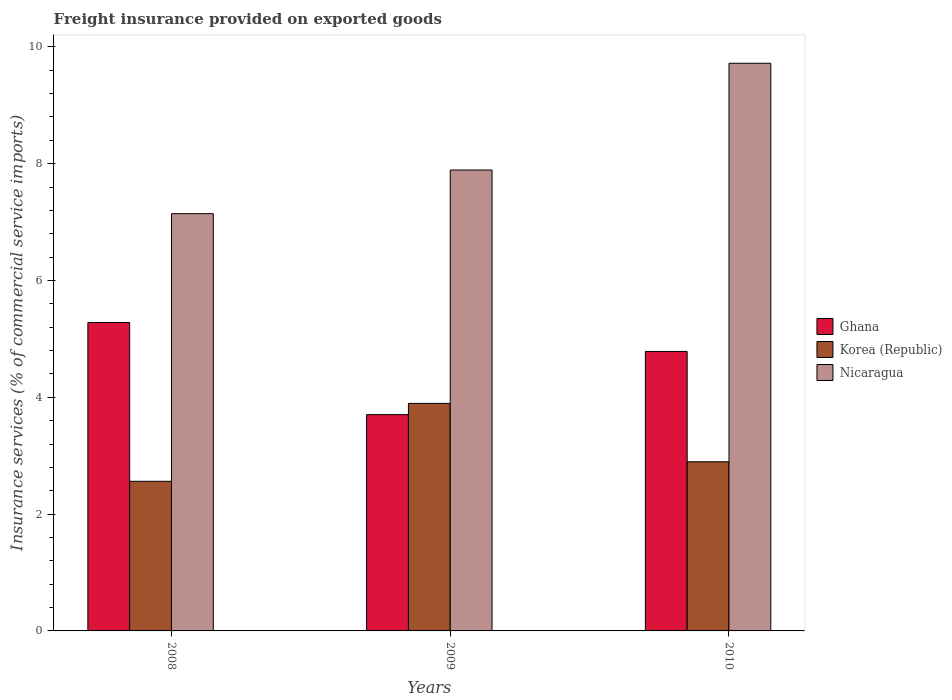Are the number of bars per tick equal to the number of legend labels?
Offer a terse response. Yes. How many bars are there on the 1st tick from the left?
Make the answer very short. 3. How many bars are there on the 1st tick from the right?
Your answer should be compact. 3. What is the label of the 2nd group of bars from the left?
Offer a very short reply. 2009. In how many cases, is the number of bars for a given year not equal to the number of legend labels?
Offer a terse response. 0. What is the freight insurance provided on exported goods in Nicaragua in 2008?
Provide a short and direct response. 7.14. Across all years, what is the maximum freight insurance provided on exported goods in Nicaragua?
Offer a very short reply. 9.72. Across all years, what is the minimum freight insurance provided on exported goods in Ghana?
Ensure brevity in your answer.  3.7. What is the total freight insurance provided on exported goods in Korea (Republic) in the graph?
Provide a short and direct response. 9.35. What is the difference between the freight insurance provided on exported goods in Nicaragua in 2008 and that in 2010?
Your answer should be compact. -2.58. What is the difference between the freight insurance provided on exported goods in Ghana in 2010 and the freight insurance provided on exported goods in Nicaragua in 2009?
Provide a short and direct response. -3.11. What is the average freight insurance provided on exported goods in Korea (Republic) per year?
Ensure brevity in your answer.  3.12. In the year 2010, what is the difference between the freight insurance provided on exported goods in Nicaragua and freight insurance provided on exported goods in Ghana?
Your response must be concise. 4.93. In how many years, is the freight insurance provided on exported goods in Korea (Republic) greater than 0.4 %?
Your response must be concise. 3. What is the ratio of the freight insurance provided on exported goods in Ghana in 2009 to that in 2010?
Ensure brevity in your answer.  0.77. Is the freight insurance provided on exported goods in Ghana in 2009 less than that in 2010?
Your answer should be very brief. Yes. Is the difference between the freight insurance provided on exported goods in Nicaragua in 2008 and 2010 greater than the difference between the freight insurance provided on exported goods in Ghana in 2008 and 2010?
Provide a short and direct response. No. What is the difference between the highest and the second highest freight insurance provided on exported goods in Ghana?
Give a very brief answer. 0.5. What is the difference between the highest and the lowest freight insurance provided on exported goods in Ghana?
Provide a succinct answer. 1.58. In how many years, is the freight insurance provided on exported goods in Korea (Republic) greater than the average freight insurance provided on exported goods in Korea (Republic) taken over all years?
Give a very brief answer. 1. Is the sum of the freight insurance provided on exported goods in Nicaragua in 2008 and 2009 greater than the maximum freight insurance provided on exported goods in Ghana across all years?
Your answer should be very brief. Yes. What does the 3rd bar from the left in 2008 represents?
Give a very brief answer. Nicaragua. How many years are there in the graph?
Your answer should be very brief. 3. Are the values on the major ticks of Y-axis written in scientific E-notation?
Offer a very short reply. No. Does the graph contain any zero values?
Your response must be concise. No. Where does the legend appear in the graph?
Ensure brevity in your answer.  Center right. How are the legend labels stacked?
Provide a succinct answer. Vertical. What is the title of the graph?
Your answer should be compact. Freight insurance provided on exported goods. What is the label or title of the X-axis?
Your answer should be compact. Years. What is the label or title of the Y-axis?
Provide a succinct answer. Insurance services (% of commercial service imports). What is the Insurance services (% of commercial service imports) in Ghana in 2008?
Give a very brief answer. 5.28. What is the Insurance services (% of commercial service imports) of Korea (Republic) in 2008?
Make the answer very short. 2.56. What is the Insurance services (% of commercial service imports) in Nicaragua in 2008?
Provide a succinct answer. 7.14. What is the Insurance services (% of commercial service imports) in Ghana in 2009?
Keep it short and to the point. 3.7. What is the Insurance services (% of commercial service imports) of Korea (Republic) in 2009?
Your answer should be compact. 3.9. What is the Insurance services (% of commercial service imports) of Nicaragua in 2009?
Offer a terse response. 7.89. What is the Insurance services (% of commercial service imports) in Ghana in 2010?
Provide a succinct answer. 4.79. What is the Insurance services (% of commercial service imports) in Korea (Republic) in 2010?
Offer a very short reply. 2.9. What is the Insurance services (% of commercial service imports) of Nicaragua in 2010?
Keep it short and to the point. 9.72. Across all years, what is the maximum Insurance services (% of commercial service imports) of Ghana?
Make the answer very short. 5.28. Across all years, what is the maximum Insurance services (% of commercial service imports) in Korea (Republic)?
Provide a short and direct response. 3.9. Across all years, what is the maximum Insurance services (% of commercial service imports) in Nicaragua?
Keep it short and to the point. 9.72. Across all years, what is the minimum Insurance services (% of commercial service imports) in Ghana?
Offer a very short reply. 3.7. Across all years, what is the minimum Insurance services (% of commercial service imports) of Korea (Republic)?
Provide a short and direct response. 2.56. Across all years, what is the minimum Insurance services (% of commercial service imports) in Nicaragua?
Offer a terse response. 7.14. What is the total Insurance services (% of commercial service imports) of Ghana in the graph?
Your response must be concise. 13.77. What is the total Insurance services (% of commercial service imports) in Korea (Republic) in the graph?
Ensure brevity in your answer.  9.35. What is the total Insurance services (% of commercial service imports) in Nicaragua in the graph?
Offer a terse response. 24.75. What is the difference between the Insurance services (% of commercial service imports) of Ghana in 2008 and that in 2009?
Provide a succinct answer. 1.58. What is the difference between the Insurance services (% of commercial service imports) in Korea (Republic) in 2008 and that in 2009?
Ensure brevity in your answer.  -1.33. What is the difference between the Insurance services (% of commercial service imports) in Nicaragua in 2008 and that in 2009?
Ensure brevity in your answer.  -0.75. What is the difference between the Insurance services (% of commercial service imports) of Ghana in 2008 and that in 2010?
Your response must be concise. 0.5. What is the difference between the Insurance services (% of commercial service imports) in Korea (Republic) in 2008 and that in 2010?
Offer a very short reply. -0.33. What is the difference between the Insurance services (% of commercial service imports) of Nicaragua in 2008 and that in 2010?
Provide a short and direct response. -2.58. What is the difference between the Insurance services (% of commercial service imports) in Ghana in 2009 and that in 2010?
Offer a terse response. -1.08. What is the difference between the Insurance services (% of commercial service imports) of Korea (Republic) in 2009 and that in 2010?
Ensure brevity in your answer.  1. What is the difference between the Insurance services (% of commercial service imports) of Nicaragua in 2009 and that in 2010?
Give a very brief answer. -1.83. What is the difference between the Insurance services (% of commercial service imports) in Ghana in 2008 and the Insurance services (% of commercial service imports) in Korea (Republic) in 2009?
Your answer should be very brief. 1.39. What is the difference between the Insurance services (% of commercial service imports) in Ghana in 2008 and the Insurance services (% of commercial service imports) in Nicaragua in 2009?
Provide a succinct answer. -2.61. What is the difference between the Insurance services (% of commercial service imports) of Korea (Republic) in 2008 and the Insurance services (% of commercial service imports) of Nicaragua in 2009?
Make the answer very short. -5.33. What is the difference between the Insurance services (% of commercial service imports) in Ghana in 2008 and the Insurance services (% of commercial service imports) in Korea (Republic) in 2010?
Provide a short and direct response. 2.39. What is the difference between the Insurance services (% of commercial service imports) in Ghana in 2008 and the Insurance services (% of commercial service imports) in Nicaragua in 2010?
Ensure brevity in your answer.  -4.44. What is the difference between the Insurance services (% of commercial service imports) in Korea (Republic) in 2008 and the Insurance services (% of commercial service imports) in Nicaragua in 2010?
Your response must be concise. -7.16. What is the difference between the Insurance services (% of commercial service imports) of Ghana in 2009 and the Insurance services (% of commercial service imports) of Korea (Republic) in 2010?
Your response must be concise. 0.81. What is the difference between the Insurance services (% of commercial service imports) in Ghana in 2009 and the Insurance services (% of commercial service imports) in Nicaragua in 2010?
Provide a short and direct response. -6.02. What is the difference between the Insurance services (% of commercial service imports) in Korea (Republic) in 2009 and the Insurance services (% of commercial service imports) in Nicaragua in 2010?
Ensure brevity in your answer.  -5.82. What is the average Insurance services (% of commercial service imports) in Ghana per year?
Provide a short and direct response. 4.59. What is the average Insurance services (% of commercial service imports) of Korea (Republic) per year?
Provide a succinct answer. 3.12. What is the average Insurance services (% of commercial service imports) of Nicaragua per year?
Your response must be concise. 8.25. In the year 2008, what is the difference between the Insurance services (% of commercial service imports) in Ghana and Insurance services (% of commercial service imports) in Korea (Republic)?
Make the answer very short. 2.72. In the year 2008, what is the difference between the Insurance services (% of commercial service imports) in Ghana and Insurance services (% of commercial service imports) in Nicaragua?
Make the answer very short. -1.86. In the year 2008, what is the difference between the Insurance services (% of commercial service imports) in Korea (Republic) and Insurance services (% of commercial service imports) in Nicaragua?
Make the answer very short. -4.58. In the year 2009, what is the difference between the Insurance services (% of commercial service imports) of Ghana and Insurance services (% of commercial service imports) of Korea (Republic)?
Your answer should be compact. -0.19. In the year 2009, what is the difference between the Insurance services (% of commercial service imports) of Ghana and Insurance services (% of commercial service imports) of Nicaragua?
Ensure brevity in your answer.  -4.19. In the year 2009, what is the difference between the Insurance services (% of commercial service imports) of Korea (Republic) and Insurance services (% of commercial service imports) of Nicaragua?
Make the answer very short. -4. In the year 2010, what is the difference between the Insurance services (% of commercial service imports) in Ghana and Insurance services (% of commercial service imports) in Korea (Republic)?
Provide a short and direct response. 1.89. In the year 2010, what is the difference between the Insurance services (% of commercial service imports) of Ghana and Insurance services (% of commercial service imports) of Nicaragua?
Provide a short and direct response. -4.93. In the year 2010, what is the difference between the Insurance services (% of commercial service imports) of Korea (Republic) and Insurance services (% of commercial service imports) of Nicaragua?
Ensure brevity in your answer.  -6.82. What is the ratio of the Insurance services (% of commercial service imports) in Ghana in 2008 to that in 2009?
Ensure brevity in your answer.  1.43. What is the ratio of the Insurance services (% of commercial service imports) of Korea (Republic) in 2008 to that in 2009?
Provide a succinct answer. 0.66. What is the ratio of the Insurance services (% of commercial service imports) of Nicaragua in 2008 to that in 2009?
Your response must be concise. 0.91. What is the ratio of the Insurance services (% of commercial service imports) in Ghana in 2008 to that in 2010?
Make the answer very short. 1.1. What is the ratio of the Insurance services (% of commercial service imports) of Korea (Republic) in 2008 to that in 2010?
Your answer should be very brief. 0.88. What is the ratio of the Insurance services (% of commercial service imports) of Nicaragua in 2008 to that in 2010?
Ensure brevity in your answer.  0.73. What is the ratio of the Insurance services (% of commercial service imports) of Ghana in 2009 to that in 2010?
Offer a terse response. 0.77. What is the ratio of the Insurance services (% of commercial service imports) in Korea (Republic) in 2009 to that in 2010?
Ensure brevity in your answer.  1.35. What is the ratio of the Insurance services (% of commercial service imports) of Nicaragua in 2009 to that in 2010?
Offer a very short reply. 0.81. What is the difference between the highest and the second highest Insurance services (% of commercial service imports) of Ghana?
Give a very brief answer. 0.5. What is the difference between the highest and the second highest Insurance services (% of commercial service imports) in Korea (Republic)?
Your answer should be very brief. 1. What is the difference between the highest and the second highest Insurance services (% of commercial service imports) of Nicaragua?
Ensure brevity in your answer.  1.83. What is the difference between the highest and the lowest Insurance services (% of commercial service imports) in Ghana?
Offer a very short reply. 1.58. What is the difference between the highest and the lowest Insurance services (% of commercial service imports) in Korea (Republic)?
Your answer should be compact. 1.33. What is the difference between the highest and the lowest Insurance services (% of commercial service imports) in Nicaragua?
Ensure brevity in your answer.  2.58. 